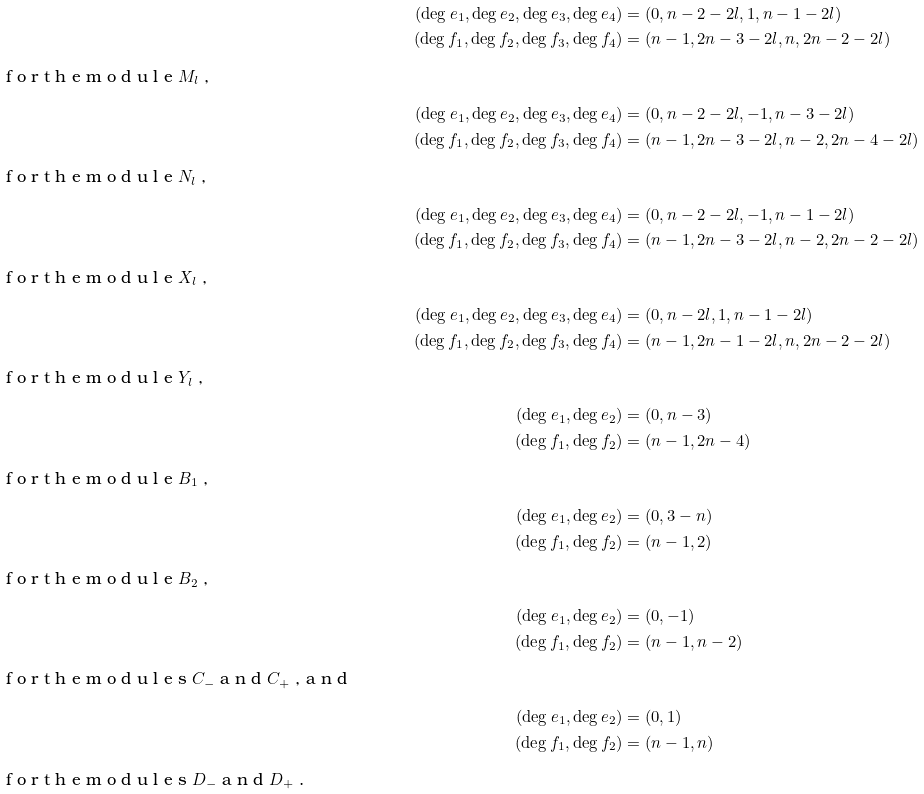<formula> <loc_0><loc_0><loc_500><loc_500>( \deg e _ { 1 } , \deg e _ { 2 } , \deg e _ { 3 } , \deg e _ { 4 } ) & = ( 0 , n - 2 - 2 l , 1 , n - 1 - 2 l ) \\ ( \deg f _ { 1 } , \deg f _ { 2 } , \deg f _ { 3 } , \deg f _ { 4 } ) & = ( n - 1 , 2 n - 3 - 2 l , n , 2 n - 2 - 2 l ) \\ \intertext { f o r t h e m o d u l e $ M _ { l } $ , } ( \deg e _ { 1 } , \deg e _ { 2 } , \deg e _ { 3 } , \deg e _ { 4 } ) & = ( 0 , n - 2 - 2 l , - 1 , n - 3 - 2 l ) \\ ( \deg f _ { 1 } , \deg f _ { 2 } , \deg f _ { 3 } , \deg f _ { 4 } ) & = ( n - 1 , 2 n - 3 - 2 l , n - 2 , 2 n - 4 - 2 l ) \\ \intertext { f o r t h e m o d u l e $ N _ { l } $ , } ( \deg e _ { 1 } , \deg e _ { 2 } , \deg e _ { 3 } , \deg e _ { 4 } ) & = ( 0 , n - 2 - 2 l , - 1 , n - 1 - 2 l ) \\ ( \deg f _ { 1 } , \deg f _ { 2 } , \deg f _ { 3 } , \deg f _ { 4 } ) & = ( n - 1 , 2 n - 3 - 2 l , n - 2 , 2 n - 2 - 2 l ) \\ \intertext { f o r t h e m o d u l e $ X _ { l } $ , } ( \deg e _ { 1 } , \deg e _ { 2 } , \deg e _ { 3 } , \deg e _ { 4 } ) & = ( 0 , n - 2 l , 1 , n - 1 - 2 l ) \\ ( \deg f _ { 1 } , \deg f _ { 2 } , \deg f _ { 3 } , \deg f _ { 4 } ) & = ( n - 1 , 2 n - 1 - 2 l , n , 2 n - 2 - 2 l ) \\ \intertext { f o r t h e m o d u l e $ Y _ { l } $ , } ( \deg e _ { 1 } , \deg e _ { 2 } ) & = ( 0 , n - 3 ) \\ ( \deg f _ { 1 } , \deg f _ { 2 } ) & = ( n - 1 , 2 n - 4 ) \intertext { f o r t h e m o d u l e $ B _ { 1 } $ , } ( \deg e _ { 1 } , \deg e _ { 2 } ) & = ( 0 , 3 - n ) \\ ( \deg f _ { 1 } , \deg f _ { 2 } ) & = ( n - 1 , 2 ) \intertext { f o r t h e m o d u l e $ B _ { 2 } $ , } ( \deg e _ { 1 } , \deg e _ { 2 } ) & = ( 0 , - 1 ) \\ ( \deg f _ { 1 } , \deg f _ { 2 } ) & = ( n - 1 , n - 2 ) \intertext { f o r t h e m o d u l e s $ C _ { - } $ a n d $ C _ { + } $ , a n d } ( \deg e _ { 1 } , \deg e _ { 2 } ) & = ( 0 , 1 ) \\ ( \deg f _ { 1 } , \deg f _ { 2 } ) & = ( n - 1 , n ) \intertext { f o r t h e m o d u l e s $ D _ { - } $ a n d $ D _ { + } $ . }</formula> 